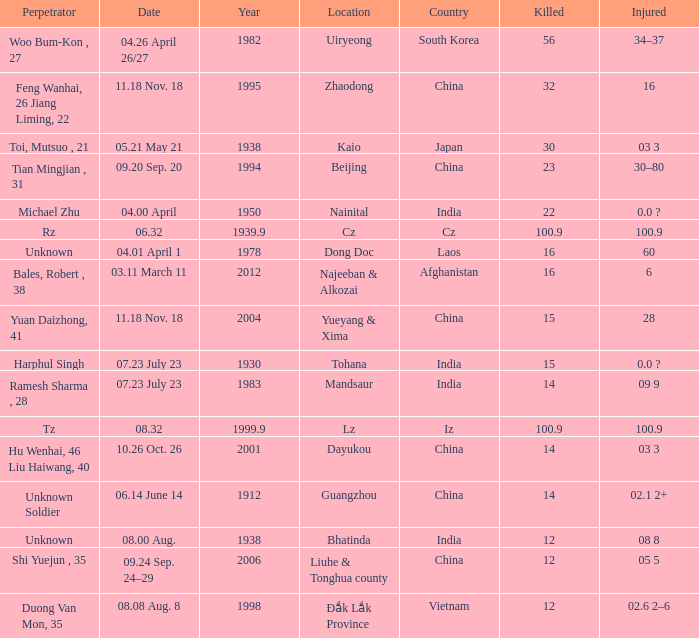What is the date, when the country is "china", and the perpetrator is "shi yuejun , 35"? 09.24 Sep. 24–29. 